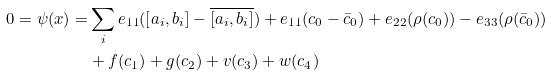Convert formula to latex. <formula><loc_0><loc_0><loc_500><loc_500>0 = \psi ( x ) = & \sum _ { i } e _ { 1 1 } ( [ a _ { i } , b _ { i } ] - \overline { [ a _ { i } , b _ { i } ] } ) + e _ { 1 1 } ( c _ { 0 } - \bar { c } _ { 0 } ) + e _ { 2 2 } ( \rho ( c _ { 0 } ) ) - e _ { 3 3 } ( \rho ( \bar { c } _ { 0 } ) ) \\ & + { f } ( c _ { 1 } ) + { g } ( c _ { 2 } ) + { v } ( c _ { 3 } ) + { w } ( c _ { 4 } )</formula> 